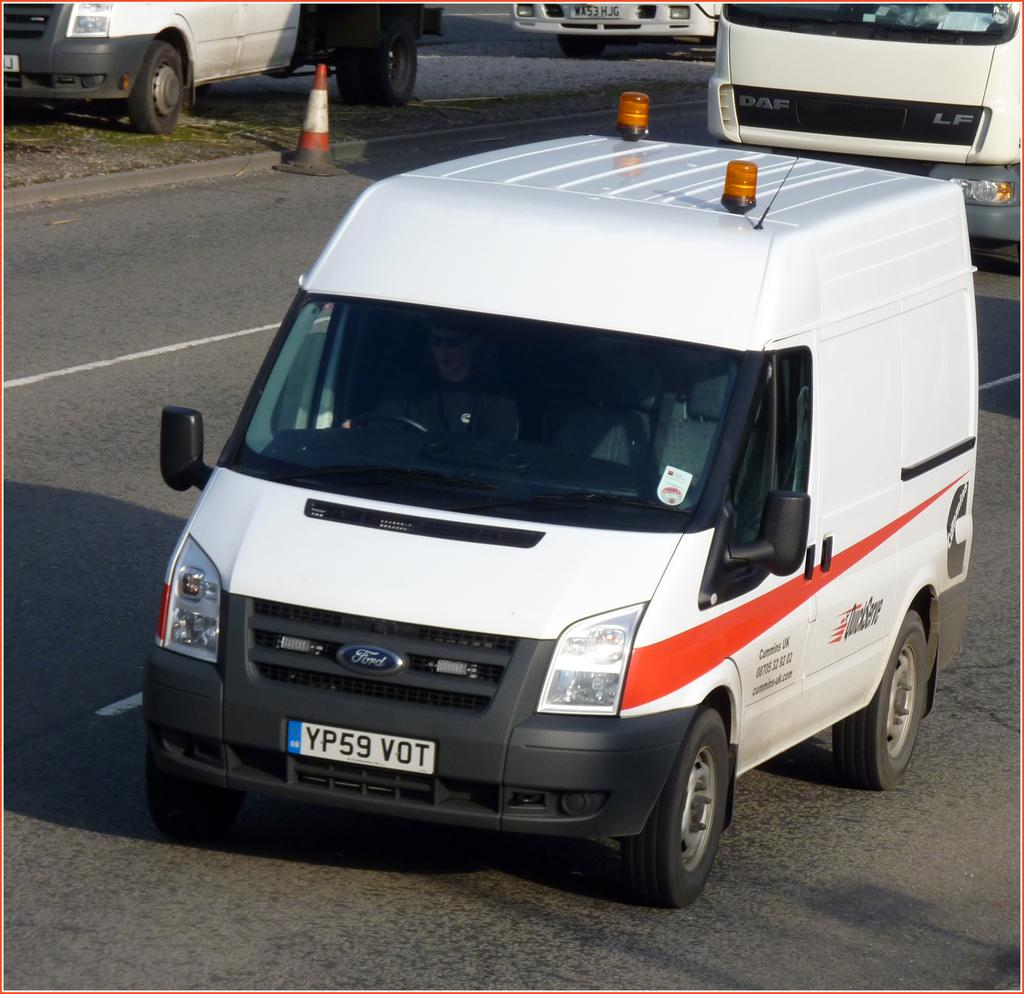<image>
Summarize the visual content of the image. A white Ford van with the tag YP59 VOT. 